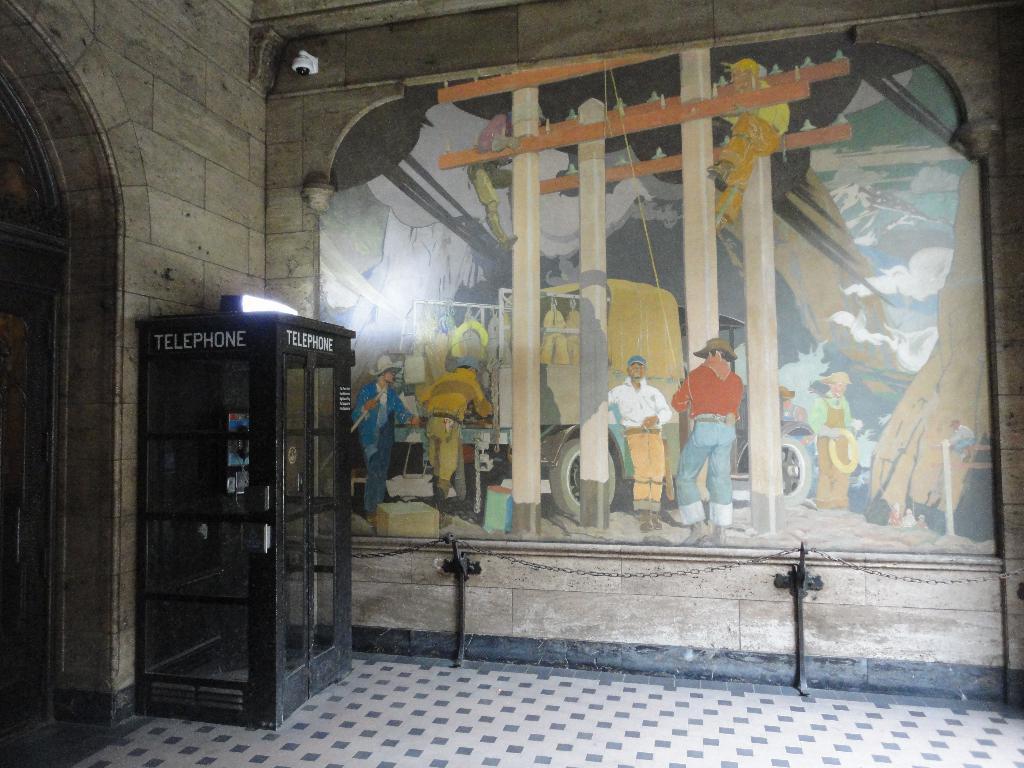How would you summarize this image in a sentence or two? This looks like a wall painting on the wall. I can see an iron chain, which is hanging to the poles. This looks like a telephone booth. I can see a security camera, which is attached to the wall. This looks like an arch. 